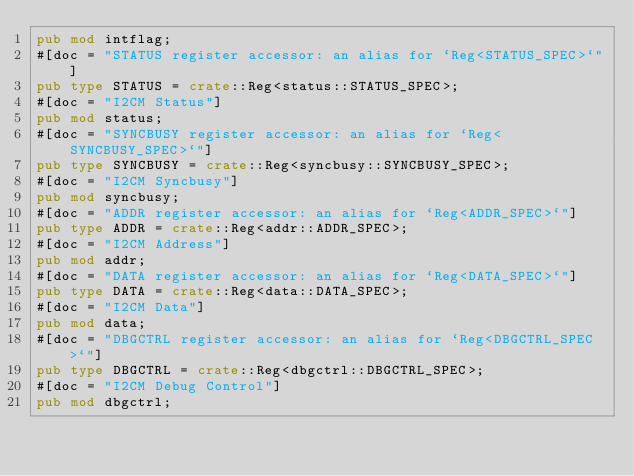<code> <loc_0><loc_0><loc_500><loc_500><_Rust_>pub mod intflag;
#[doc = "STATUS register accessor: an alias for `Reg<STATUS_SPEC>`"]
pub type STATUS = crate::Reg<status::STATUS_SPEC>;
#[doc = "I2CM Status"]
pub mod status;
#[doc = "SYNCBUSY register accessor: an alias for `Reg<SYNCBUSY_SPEC>`"]
pub type SYNCBUSY = crate::Reg<syncbusy::SYNCBUSY_SPEC>;
#[doc = "I2CM Syncbusy"]
pub mod syncbusy;
#[doc = "ADDR register accessor: an alias for `Reg<ADDR_SPEC>`"]
pub type ADDR = crate::Reg<addr::ADDR_SPEC>;
#[doc = "I2CM Address"]
pub mod addr;
#[doc = "DATA register accessor: an alias for `Reg<DATA_SPEC>`"]
pub type DATA = crate::Reg<data::DATA_SPEC>;
#[doc = "I2CM Data"]
pub mod data;
#[doc = "DBGCTRL register accessor: an alias for `Reg<DBGCTRL_SPEC>`"]
pub type DBGCTRL = crate::Reg<dbgctrl::DBGCTRL_SPEC>;
#[doc = "I2CM Debug Control"]
pub mod dbgctrl;
</code> 